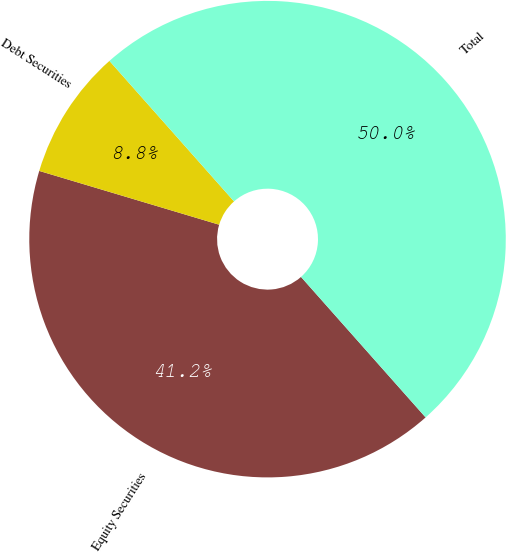<chart> <loc_0><loc_0><loc_500><loc_500><pie_chart><fcel>Equity Securities<fcel>Debt Securities<fcel>Total<nl><fcel>41.17%<fcel>8.83%<fcel>50.0%<nl></chart> 